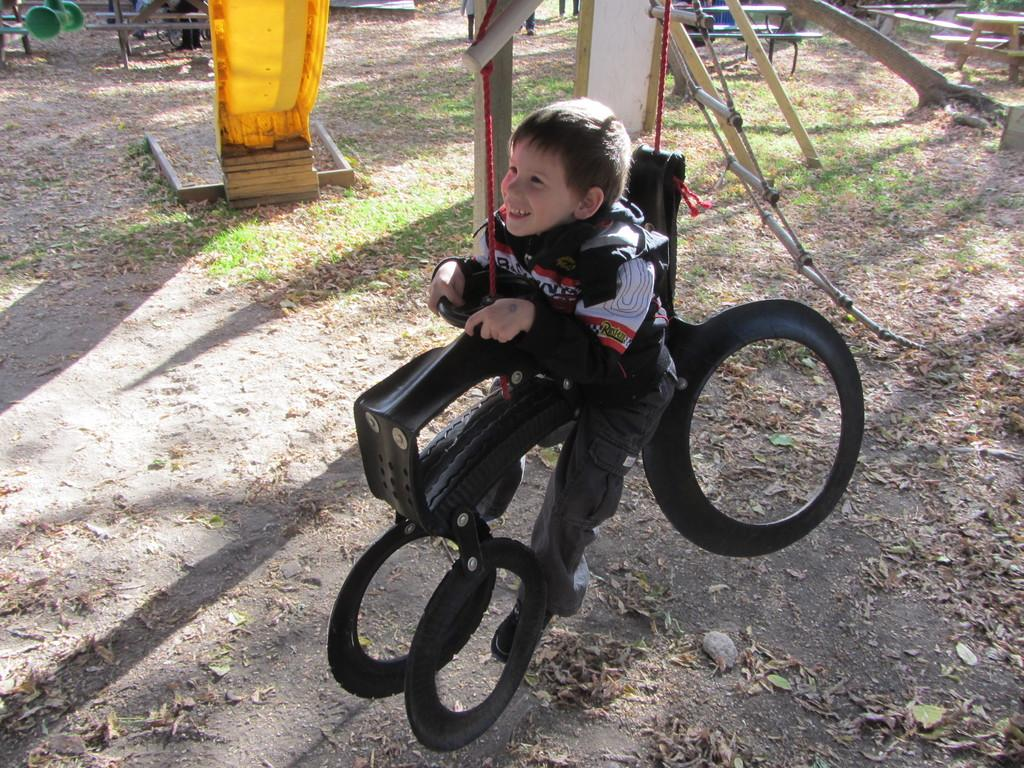Who is the main subject in the image? There is a boy in the image. What is the boy doing in the image? The boy is sitting on a toy and playing a game. What can be seen in the background of the image? There are metal rods, grass, and poles in the background of the image. When was the image taken? The image was taken during the day. Can you read the note that the boy is holding in the image? There is no note present in the image; the boy is playing a game and sitting on a toy. 